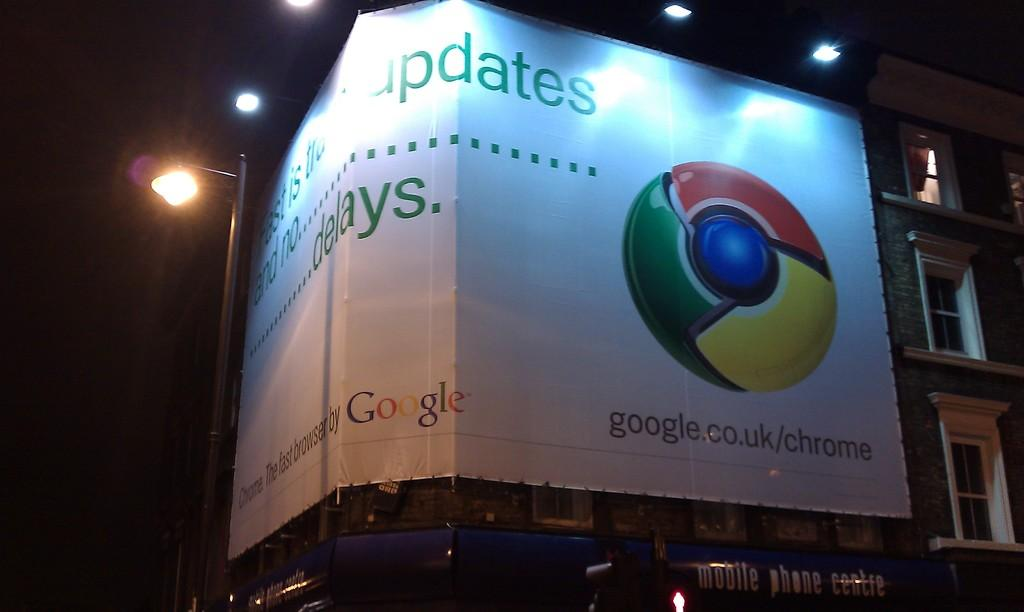<image>
Render a clear and concise summary of the photo. A corner billboard advertising google.co.uk/chrome with the chrome logo.. 